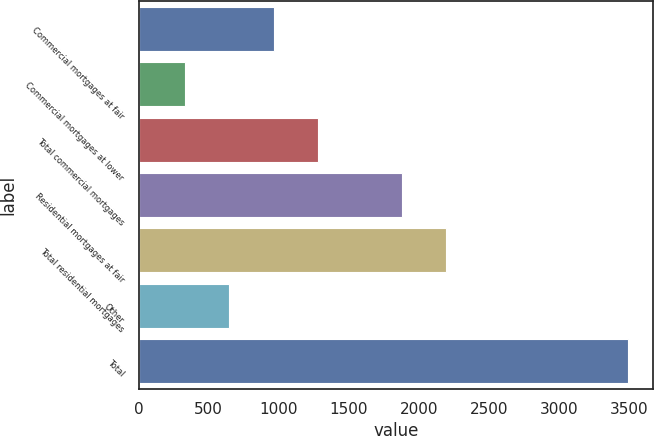Convert chart to OTSL. <chart><loc_0><loc_0><loc_500><loc_500><bar_chart><fcel>Commercial mortgages at fair<fcel>Commercial mortgages at lower<fcel>Total commercial mortgages<fcel>Residential mortgages at fair<fcel>Total residential mortgages<fcel>Other<fcel>Total<nl><fcel>962.4<fcel>330<fcel>1278.6<fcel>1878<fcel>2194.2<fcel>646.2<fcel>3492<nl></chart> 